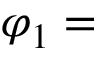<formula> <loc_0><loc_0><loc_500><loc_500>\varphi _ { 1 } =</formula> 